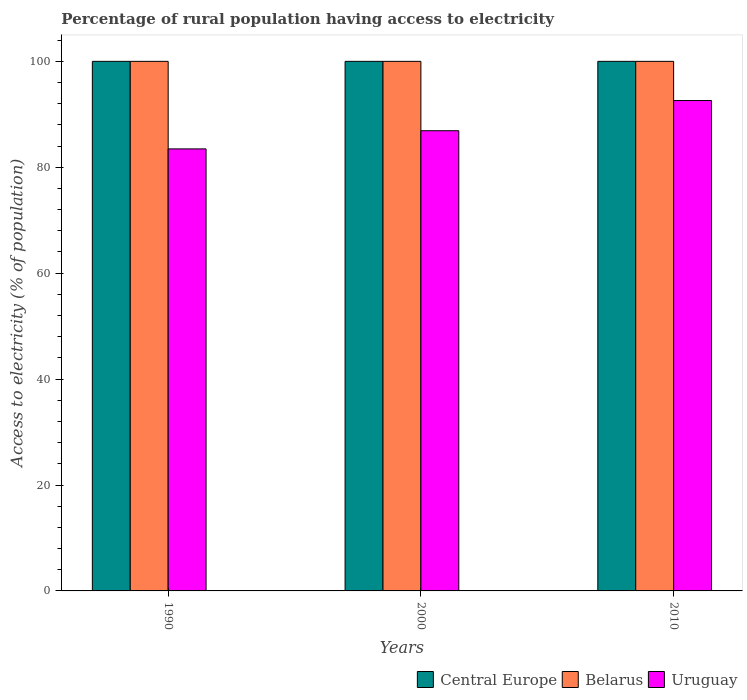How many groups of bars are there?
Make the answer very short. 3. Are the number of bars on each tick of the X-axis equal?
Keep it short and to the point. Yes. How many bars are there on the 3rd tick from the left?
Make the answer very short. 3. What is the percentage of rural population having access to electricity in Belarus in 2010?
Your answer should be compact. 100. Across all years, what is the maximum percentage of rural population having access to electricity in Belarus?
Your answer should be very brief. 100. Across all years, what is the minimum percentage of rural population having access to electricity in Central Europe?
Your response must be concise. 100. In which year was the percentage of rural population having access to electricity in Central Europe maximum?
Offer a very short reply. 1990. In which year was the percentage of rural population having access to electricity in Belarus minimum?
Your answer should be very brief. 1990. What is the total percentage of rural population having access to electricity in Uruguay in the graph?
Provide a succinct answer. 262.97. What is the difference between the percentage of rural population having access to electricity in Uruguay in 1990 and that in 2010?
Your answer should be compact. -9.13. What is the average percentage of rural population having access to electricity in Uruguay per year?
Offer a terse response. 87.66. In the year 2010, what is the difference between the percentage of rural population having access to electricity in Uruguay and percentage of rural population having access to electricity in Belarus?
Provide a short and direct response. -7.4. In how many years, is the percentage of rural population having access to electricity in Central Europe greater than 12 %?
Keep it short and to the point. 3. Is the percentage of rural population having access to electricity in Uruguay in 1990 less than that in 2000?
Ensure brevity in your answer.  Yes. What is the difference between the highest and the second highest percentage of rural population having access to electricity in Belarus?
Keep it short and to the point. 0. What is the difference between the highest and the lowest percentage of rural population having access to electricity in Belarus?
Provide a succinct answer. 0. What does the 3rd bar from the left in 1990 represents?
Offer a terse response. Uruguay. What does the 2nd bar from the right in 2000 represents?
Your answer should be very brief. Belarus. How many bars are there?
Provide a short and direct response. 9. What is the difference between two consecutive major ticks on the Y-axis?
Make the answer very short. 20. Are the values on the major ticks of Y-axis written in scientific E-notation?
Offer a terse response. No. What is the title of the graph?
Provide a short and direct response. Percentage of rural population having access to electricity. What is the label or title of the Y-axis?
Keep it short and to the point. Access to electricity (% of population). What is the Access to electricity (% of population) of Central Europe in 1990?
Your answer should be compact. 100. What is the Access to electricity (% of population) of Belarus in 1990?
Ensure brevity in your answer.  100. What is the Access to electricity (% of population) in Uruguay in 1990?
Provide a succinct answer. 83.47. What is the Access to electricity (% of population) of Belarus in 2000?
Ensure brevity in your answer.  100. What is the Access to electricity (% of population) in Uruguay in 2000?
Your response must be concise. 86.9. What is the Access to electricity (% of population) in Central Europe in 2010?
Ensure brevity in your answer.  100. What is the Access to electricity (% of population) in Uruguay in 2010?
Your answer should be very brief. 92.6. Across all years, what is the maximum Access to electricity (% of population) in Uruguay?
Your answer should be compact. 92.6. Across all years, what is the minimum Access to electricity (% of population) of Uruguay?
Keep it short and to the point. 83.47. What is the total Access to electricity (% of population) in Central Europe in the graph?
Give a very brief answer. 300. What is the total Access to electricity (% of population) in Belarus in the graph?
Provide a succinct answer. 300. What is the total Access to electricity (% of population) in Uruguay in the graph?
Your answer should be very brief. 262.97. What is the difference between the Access to electricity (% of population) in Central Europe in 1990 and that in 2000?
Your answer should be very brief. 0. What is the difference between the Access to electricity (% of population) of Uruguay in 1990 and that in 2000?
Your answer should be very brief. -3.43. What is the difference between the Access to electricity (% of population) in Belarus in 1990 and that in 2010?
Give a very brief answer. 0. What is the difference between the Access to electricity (% of population) in Uruguay in 1990 and that in 2010?
Offer a terse response. -9.13. What is the difference between the Access to electricity (% of population) of Belarus in 2000 and that in 2010?
Your answer should be compact. 0. What is the difference between the Access to electricity (% of population) of Uruguay in 2000 and that in 2010?
Offer a terse response. -5.7. What is the difference between the Access to electricity (% of population) of Central Europe in 1990 and the Access to electricity (% of population) of Belarus in 2000?
Keep it short and to the point. 0. What is the difference between the Access to electricity (% of population) of Central Europe in 1990 and the Access to electricity (% of population) of Uruguay in 2000?
Offer a very short reply. 13.1. What is the difference between the Access to electricity (% of population) in Central Europe in 1990 and the Access to electricity (% of population) in Uruguay in 2010?
Offer a terse response. 7.4. What is the difference between the Access to electricity (% of population) in Central Europe in 2000 and the Access to electricity (% of population) in Belarus in 2010?
Give a very brief answer. 0. What is the average Access to electricity (% of population) of Belarus per year?
Make the answer very short. 100. What is the average Access to electricity (% of population) of Uruguay per year?
Make the answer very short. 87.66. In the year 1990, what is the difference between the Access to electricity (% of population) of Central Europe and Access to electricity (% of population) of Belarus?
Give a very brief answer. 0. In the year 1990, what is the difference between the Access to electricity (% of population) in Central Europe and Access to electricity (% of population) in Uruguay?
Give a very brief answer. 16.53. In the year 1990, what is the difference between the Access to electricity (% of population) of Belarus and Access to electricity (% of population) of Uruguay?
Make the answer very short. 16.53. In the year 2000, what is the difference between the Access to electricity (% of population) in Central Europe and Access to electricity (% of population) in Belarus?
Offer a very short reply. 0. In the year 2000, what is the difference between the Access to electricity (% of population) in Belarus and Access to electricity (% of population) in Uruguay?
Your response must be concise. 13.1. In the year 2010, what is the difference between the Access to electricity (% of population) in Central Europe and Access to electricity (% of population) in Uruguay?
Make the answer very short. 7.4. In the year 2010, what is the difference between the Access to electricity (% of population) in Belarus and Access to electricity (% of population) in Uruguay?
Your answer should be compact. 7.4. What is the ratio of the Access to electricity (% of population) in Central Europe in 1990 to that in 2000?
Offer a very short reply. 1. What is the ratio of the Access to electricity (% of population) in Uruguay in 1990 to that in 2000?
Offer a terse response. 0.96. What is the ratio of the Access to electricity (% of population) of Central Europe in 1990 to that in 2010?
Offer a terse response. 1. What is the ratio of the Access to electricity (% of population) in Belarus in 1990 to that in 2010?
Ensure brevity in your answer.  1. What is the ratio of the Access to electricity (% of population) of Uruguay in 1990 to that in 2010?
Make the answer very short. 0.9. What is the ratio of the Access to electricity (% of population) in Belarus in 2000 to that in 2010?
Your response must be concise. 1. What is the ratio of the Access to electricity (% of population) in Uruguay in 2000 to that in 2010?
Make the answer very short. 0.94. What is the difference between the highest and the second highest Access to electricity (% of population) of Central Europe?
Ensure brevity in your answer.  0. What is the difference between the highest and the lowest Access to electricity (% of population) of Uruguay?
Give a very brief answer. 9.13. 